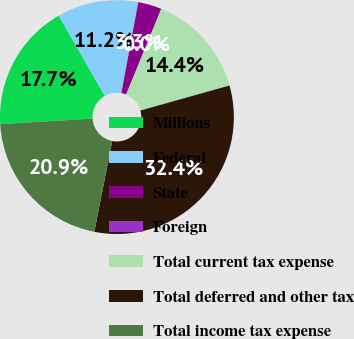Convert chart to OTSL. <chart><loc_0><loc_0><loc_500><loc_500><pie_chart><fcel>Millions<fcel>Federal<fcel>State<fcel>Foreign<fcel>Total current tax expense<fcel>Total deferred and other tax<fcel>Total income tax expense<nl><fcel>17.69%<fcel>11.21%<fcel>3.26%<fcel>0.01%<fcel>14.45%<fcel>32.45%<fcel>20.94%<nl></chart> 